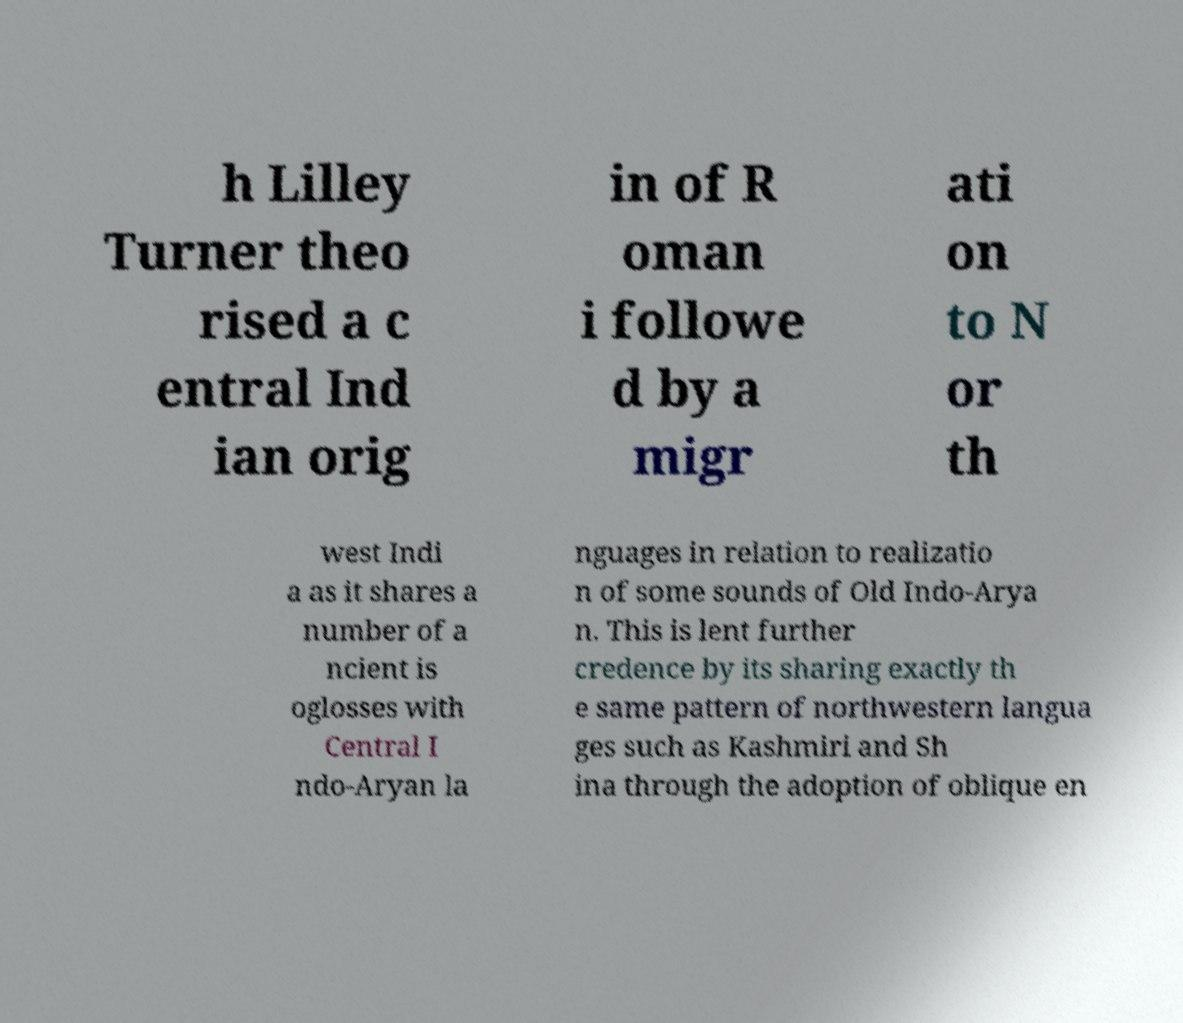There's text embedded in this image that I need extracted. Can you transcribe it verbatim? h Lilley Turner theo rised a c entral Ind ian orig in of R oman i followe d by a migr ati on to N or th west Indi a as it shares a number of a ncient is oglosses with Central I ndo-Aryan la nguages in relation to realizatio n of some sounds of Old Indo-Arya n. This is lent further credence by its sharing exactly th e same pattern of northwestern langua ges such as Kashmiri and Sh ina through the adoption of oblique en 